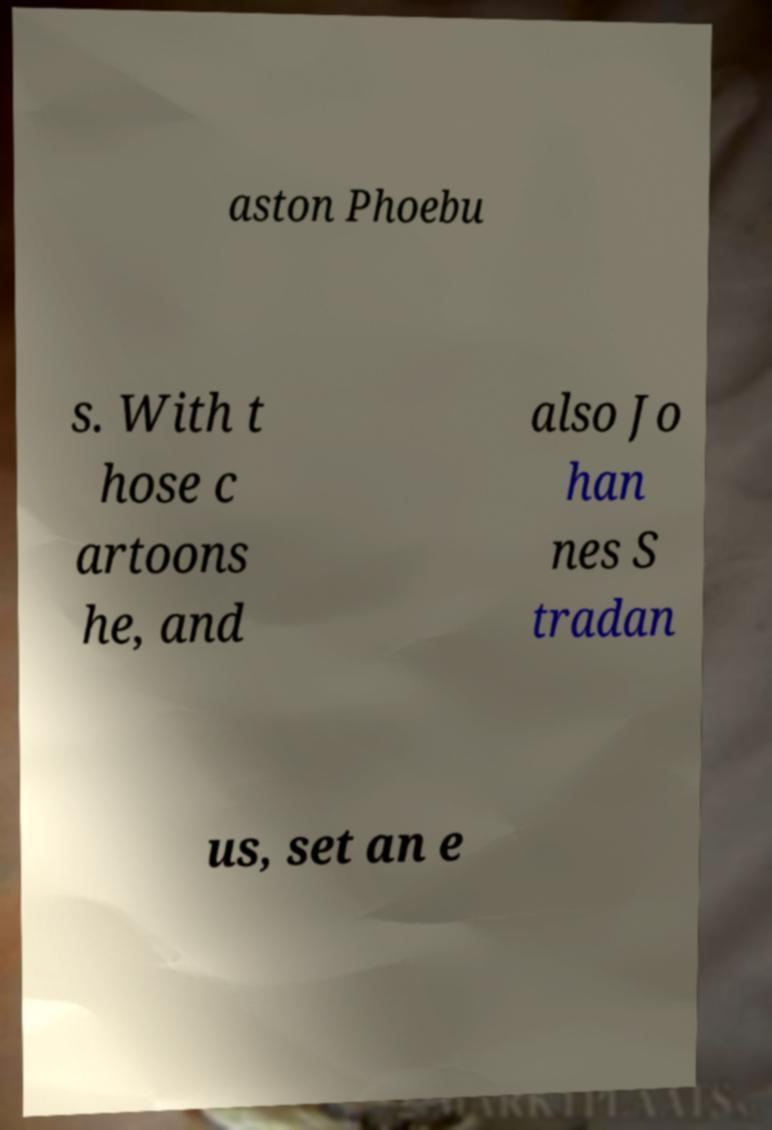There's text embedded in this image that I need extracted. Can you transcribe it verbatim? aston Phoebu s. With t hose c artoons he, and also Jo han nes S tradan us, set an e 